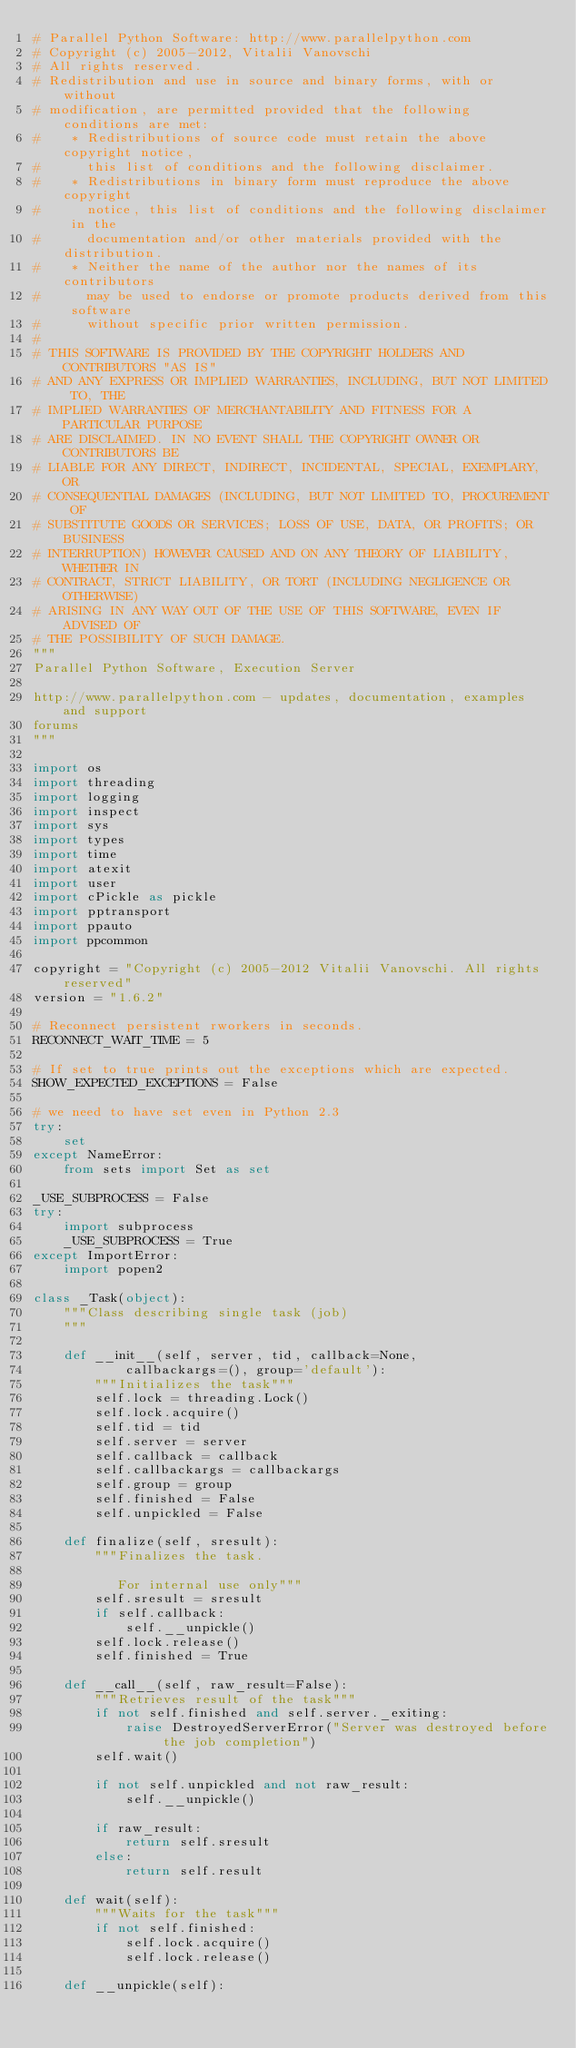<code> <loc_0><loc_0><loc_500><loc_500><_Python_># Parallel Python Software: http://www.parallelpython.com
# Copyright (c) 2005-2012, Vitalii Vanovschi
# All rights reserved.
# Redistribution and use in source and binary forms, with or without
# modification, are permitted provided that the following conditions are met:
#    * Redistributions of source code must retain the above copyright notice,
#      this list of conditions and the following disclaimer.
#    * Redistributions in binary form must reproduce the above copyright
#      notice, this list of conditions and the following disclaimer in the
#      documentation and/or other materials provided with the distribution.
#    * Neither the name of the author nor the names of its contributors
#      may be used to endorse or promote products derived from this software
#      without specific prior written permission.
#
# THIS SOFTWARE IS PROVIDED BY THE COPYRIGHT HOLDERS AND CONTRIBUTORS "AS IS"
# AND ANY EXPRESS OR IMPLIED WARRANTIES, INCLUDING, BUT NOT LIMITED TO, THE
# IMPLIED WARRANTIES OF MERCHANTABILITY AND FITNESS FOR A PARTICULAR PURPOSE
# ARE DISCLAIMED. IN NO EVENT SHALL THE COPYRIGHT OWNER OR CONTRIBUTORS BE
# LIABLE FOR ANY DIRECT, INDIRECT, INCIDENTAL, SPECIAL, EXEMPLARY, OR
# CONSEQUENTIAL DAMAGES (INCLUDING, BUT NOT LIMITED TO, PROCUREMENT OF
# SUBSTITUTE GOODS OR SERVICES; LOSS OF USE, DATA, OR PROFITS; OR BUSINESS
# INTERRUPTION) HOWEVER CAUSED AND ON ANY THEORY OF LIABILITY, WHETHER IN
# CONTRACT, STRICT LIABILITY, OR TORT (INCLUDING NEGLIGENCE OR OTHERWISE)
# ARISING IN ANY WAY OUT OF THE USE OF THIS SOFTWARE, EVEN IF ADVISED OF
# THE POSSIBILITY OF SUCH DAMAGE.
"""
Parallel Python Software, Execution Server

http://www.parallelpython.com - updates, documentation, examples and support
forums
"""

import os
import threading
import logging
import inspect
import sys
import types
import time
import atexit
import user
import cPickle as pickle
import pptransport
import ppauto
import ppcommon

copyright = "Copyright (c) 2005-2012 Vitalii Vanovschi. All rights reserved"
version = "1.6.2"

# Reconnect persistent rworkers in seconds.
RECONNECT_WAIT_TIME = 5

# If set to true prints out the exceptions which are expected.
SHOW_EXPECTED_EXCEPTIONS = False

# we need to have set even in Python 2.3
try:
    set
except NameError:
    from sets import Set as set 

_USE_SUBPROCESS = False
try:
    import subprocess
    _USE_SUBPROCESS = True
except ImportError:
    import popen2

class _Task(object):
    """Class describing single task (job)
    """

    def __init__(self, server, tid, callback=None,
            callbackargs=(), group='default'):
        """Initializes the task"""
        self.lock = threading.Lock()
        self.lock.acquire()
        self.tid = tid
        self.server = server
        self.callback = callback
        self.callbackargs = callbackargs
        self.group = group
        self.finished = False
        self.unpickled = False

    def finalize(self, sresult):
        """Finalizes the task.

           For internal use only"""
        self.sresult = sresult
        if self.callback:
            self.__unpickle()
        self.lock.release()
        self.finished = True

    def __call__(self, raw_result=False):
        """Retrieves result of the task"""
        if not self.finished and self.server._exiting:
            raise DestroyedServerError("Server was destroyed before the job completion")
        self.wait()

        if not self.unpickled and not raw_result:
            self.__unpickle()

        if raw_result:
            return self.sresult
        else:
            return self.result

    def wait(self):
        """Waits for the task"""
        if not self.finished:
            self.lock.acquire()
            self.lock.release()

    def __unpickle(self):</code> 